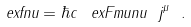<formula> <loc_0><loc_0><loc_500><loc_500>\ e x f n u = \hbar { c } \, \ e x F m u n u \ j ^ { \mu } \ .</formula> 